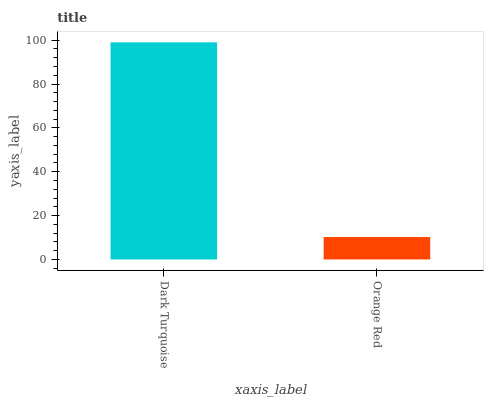Is Orange Red the minimum?
Answer yes or no. Yes. Is Dark Turquoise the maximum?
Answer yes or no. Yes. Is Orange Red the maximum?
Answer yes or no. No. Is Dark Turquoise greater than Orange Red?
Answer yes or no. Yes. Is Orange Red less than Dark Turquoise?
Answer yes or no. Yes. Is Orange Red greater than Dark Turquoise?
Answer yes or no. No. Is Dark Turquoise less than Orange Red?
Answer yes or no. No. Is Dark Turquoise the high median?
Answer yes or no. Yes. Is Orange Red the low median?
Answer yes or no. Yes. Is Orange Red the high median?
Answer yes or no. No. Is Dark Turquoise the low median?
Answer yes or no. No. 